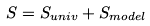<formula> <loc_0><loc_0><loc_500><loc_500>S = S _ { u n i v } + S _ { m o d e l }</formula> 